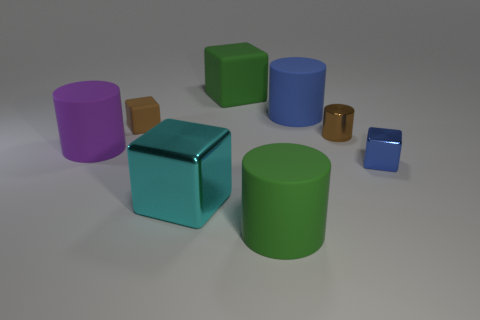What number of other things are there of the same color as the shiny cylinder?
Offer a terse response. 1. Are there fewer big matte spheres than big green things?
Make the answer very short. Yes. What number of tiny brown shiny cylinders are in front of the green matte object that is in front of the metallic object that is in front of the tiny blue block?
Keep it short and to the point. 0. There is a cylinder that is left of the small brown matte block; what is its size?
Your answer should be compact. Large. There is a shiny object that is behind the tiny blue thing; is it the same shape as the purple matte thing?
Give a very brief answer. Yes. There is a brown object that is the same shape as the tiny blue object; what material is it?
Make the answer very short. Rubber. Are there any large blue rubber cylinders?
Give a very brief answer. Yes. What is the material of the big cube behind the tiny shiny thing in front of the tiny metal thing to the left of the blue block?
Make the answer very short. Rubber. Does the large purple matte thing have the same shape as the small brown thing to the right of the large blue object?
Make the answer very short. Yes. How many small brown things are the same shape as the large cyan shiny thing?
Offer a very short reply. 1. 